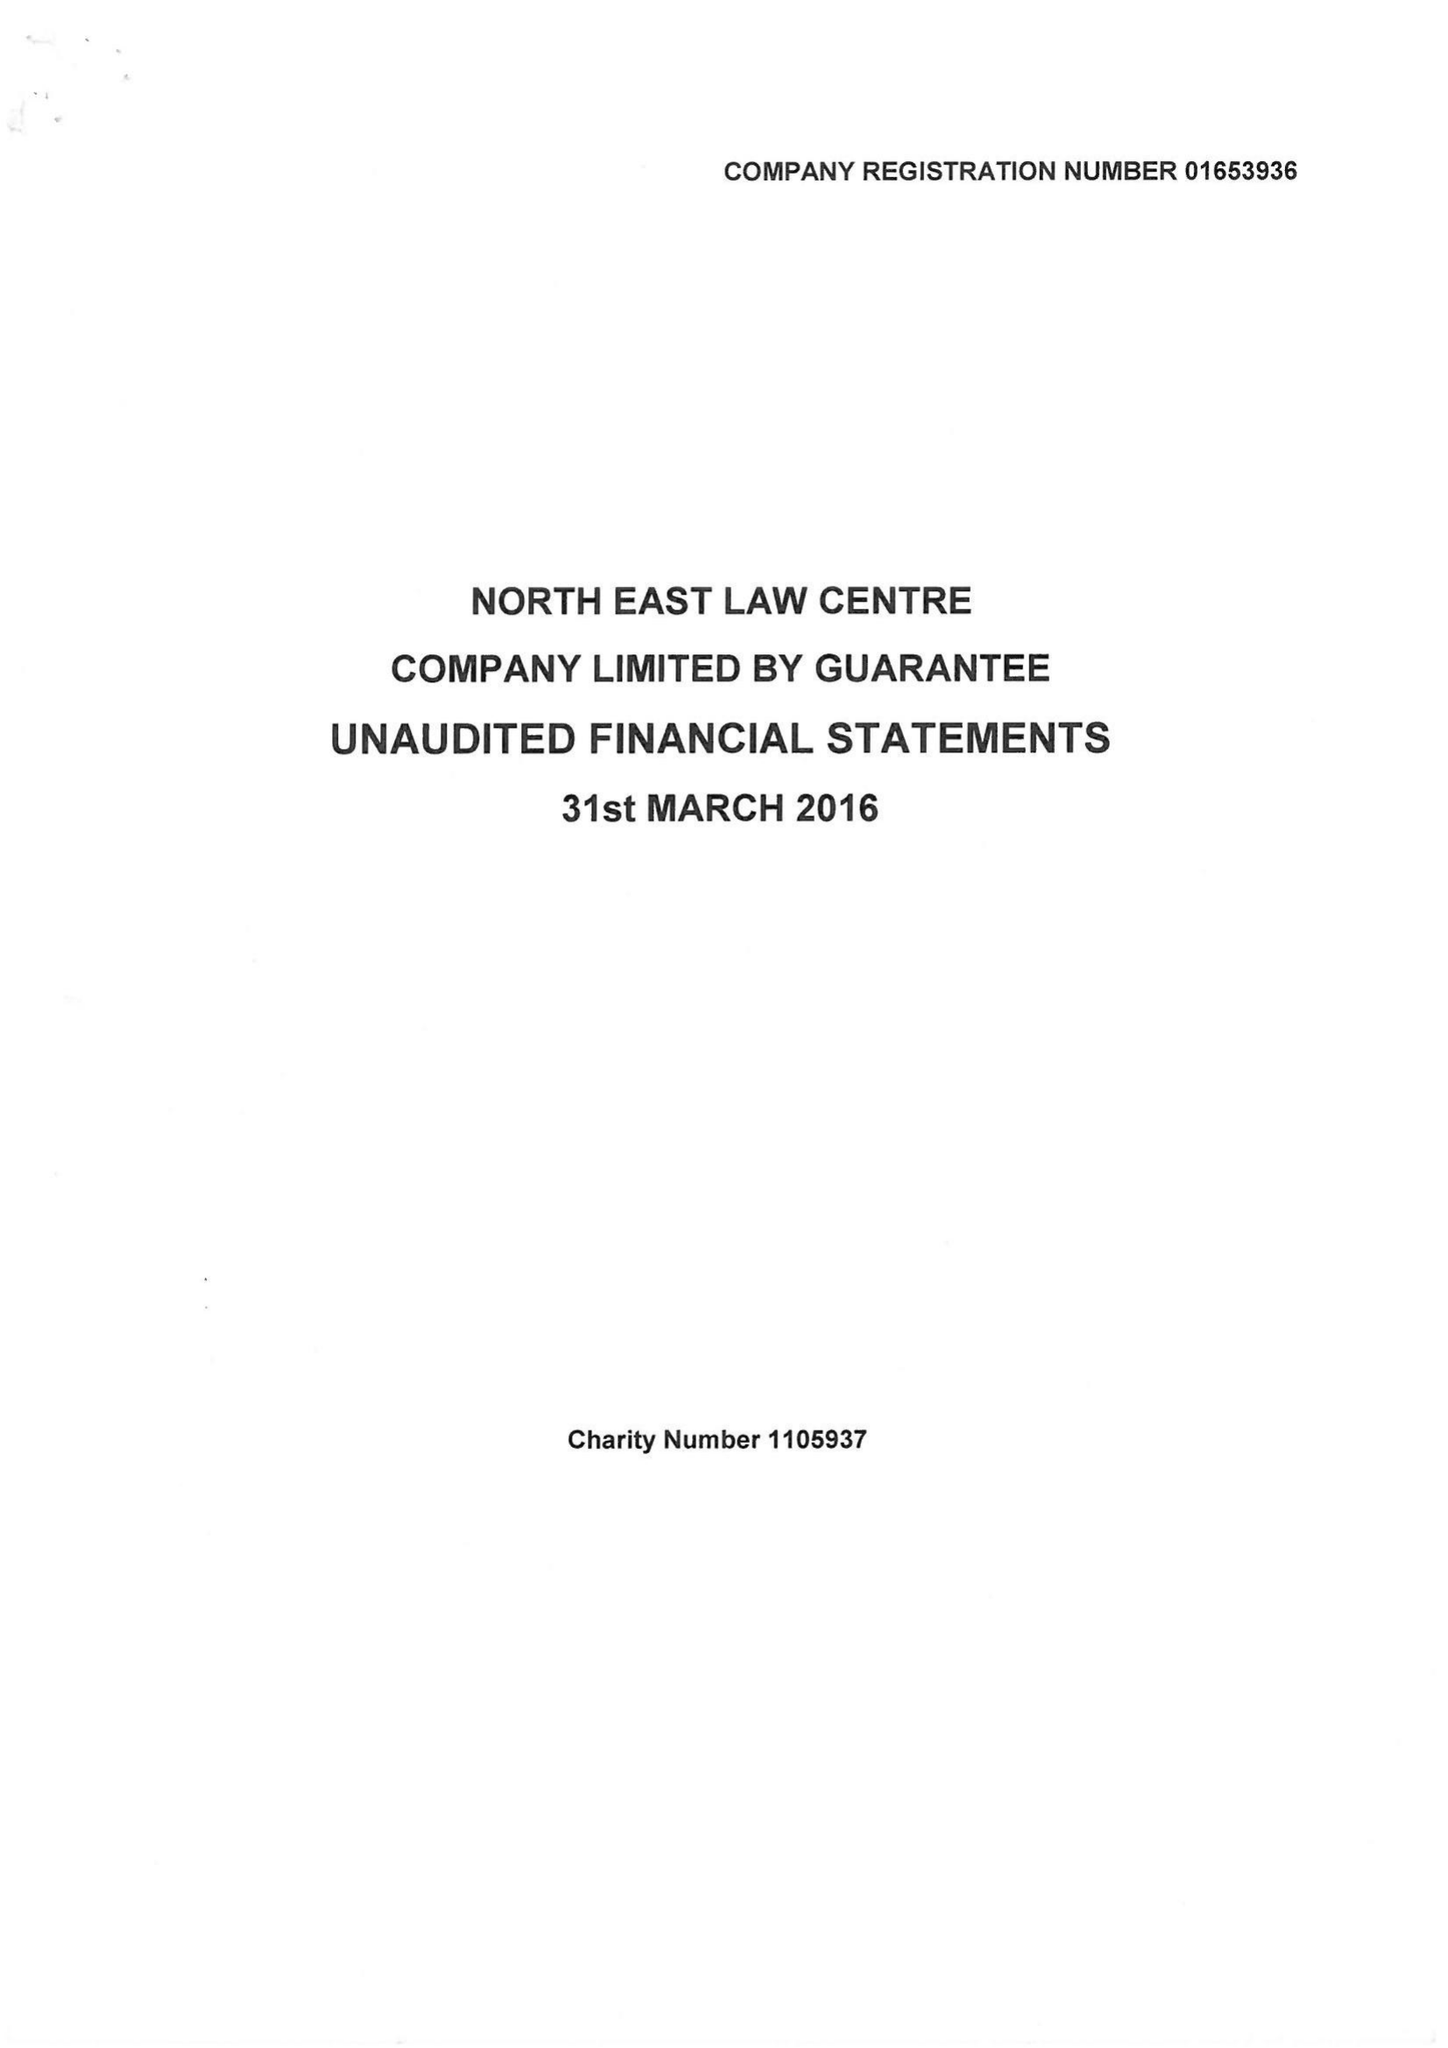What is the value for the address__street_line?
Answer the question using a single word or phrase. ELLISON PLACE 